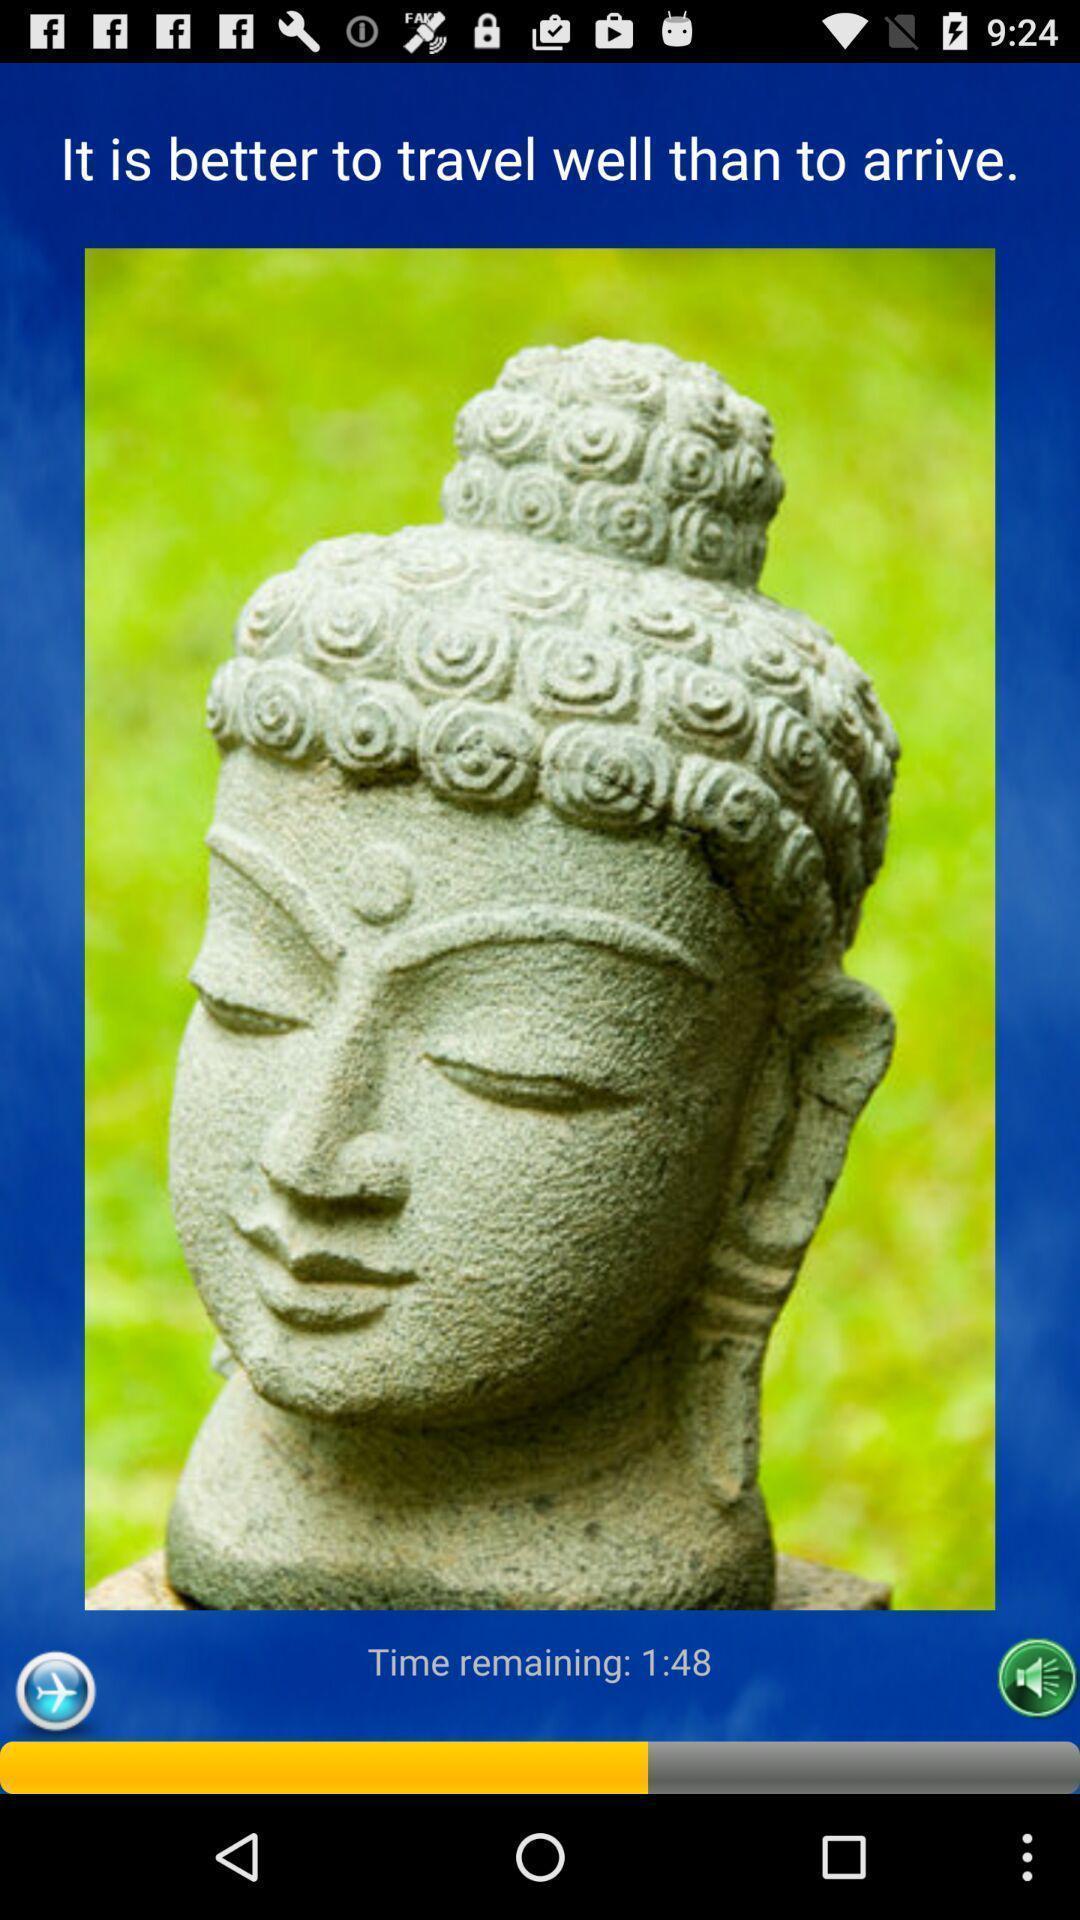Describe the key features of this screenshot. Screen displaying the image with quote. 